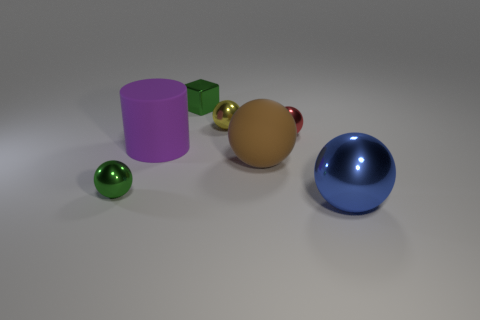There is a green shiny object that is to the left of the green metallic block; what shape is it? sphere 